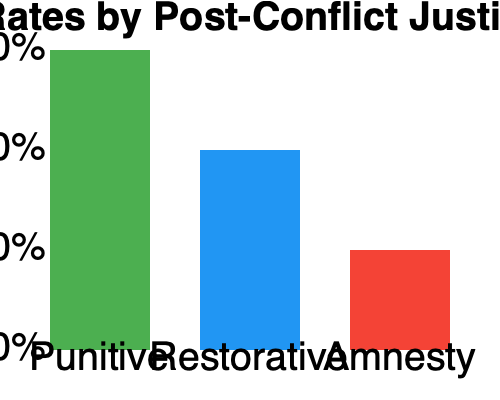Based on the bar graph comparing recidivism rates under different post-conflict justice approaches, which approach appears to be most effective in reducing repeat offenses, and how does this data support or challenge the belief in a more punitive approach? To answer this question, we need to analyze the data presented in the bar graph:

1. The graph shows recidivism rates for three post-conflict justice approaches: Punitive, Restorative, and Amnesty.

2. Recidivism rates for each approach:
   - Punitive: Approximately 60%
   - Restorative: Approximately 40%
   - Amnesty: Approximately 20%

3. Lower recidivism rates indicate greater effectiveness in reducing repeat offenses.

4. The Amnesty approach shows the lowest recidivism rate at 20%, followed by the Restorative approach at 40%, and the Punitive approach has the highest rate at 60%.

5. This data challenges the belief in a more punitive approach to post-conflict justice:
   - The punitive approach, which typically involves harsher penalties and stricter enforcement, shows the highest recidivism rate.
   - The amnesty approach, which often involves forgiveness and reintegration without punishment, shows the lowest recidivism rate.
   - The restorative approach, which focuses on reconciliation and rehabilitation, falls in the middle.

6. The data suggests that less punitive approaches (Amnesty and Restorative) may be more effective in reducing repeat offenses in post-conflict situations.

7. However, it's important to note that this graph alone doesn't provide context for other factors that might influence recidivism rates, such as the severity of initial offenses, socioeconomic conditions, or the specific implementation of each approach.
Answer: Amnesty approach; challenges punitive belief by showing lowest recidivism rate. 